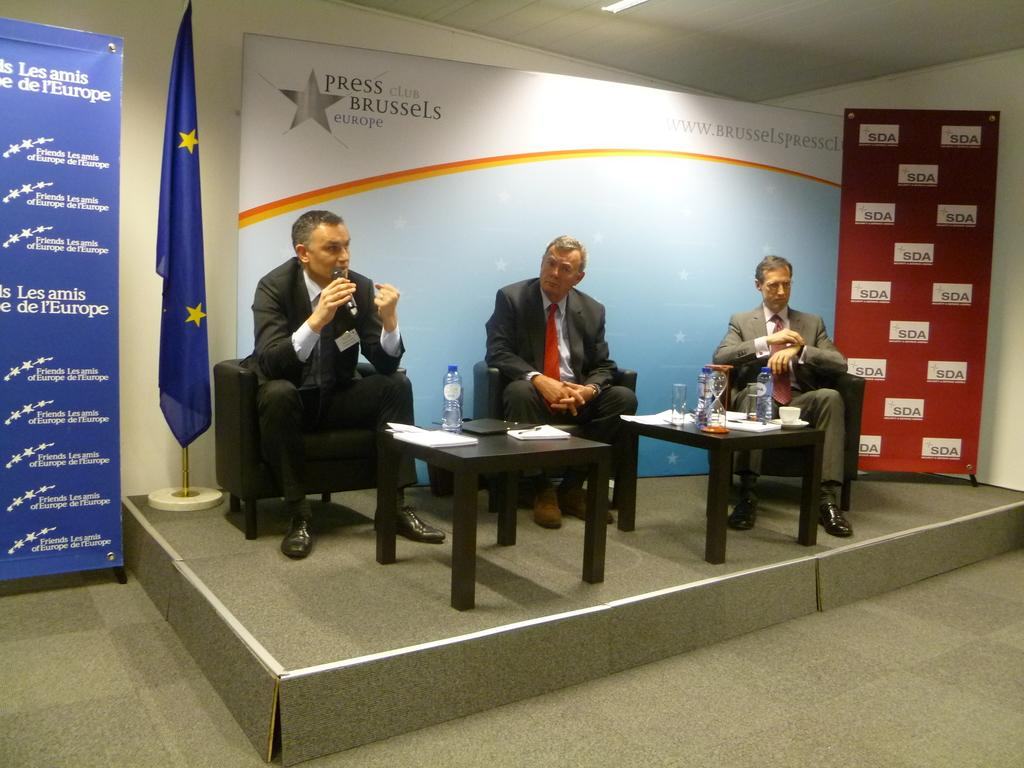How many people are in the image? There are three men in the image. What are the men doing in the image? The men are sitting on chairs. What is present on the table in the image? There is a water bottle and papers on the table. What type of lizards can be seen crawling on the papers in the image? There are no lizards present in the image; the image only shows three men sitting on chairs and a table with a water bottle and papers. 